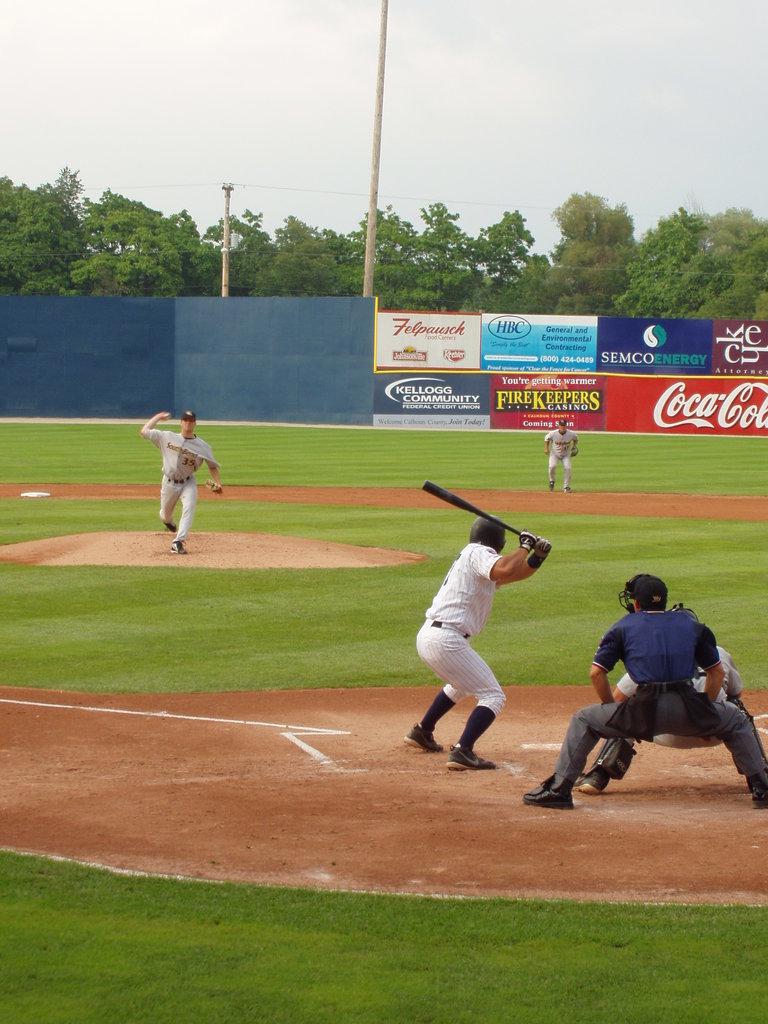What number is on the pitcher's uniform?
Make the answer very short. 35. 